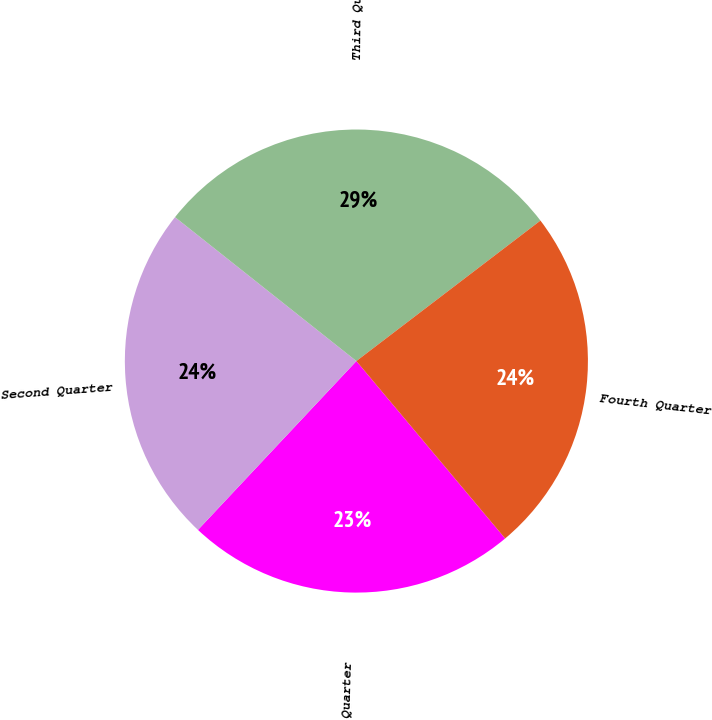Convert chart to OTSL. <chart><loc_0><loc_0><loc_500><loc_500><pie_chart><fcel>First Quarter<fcel>Second Quarter<fcel>Third Quarter<fcel>Fourth Quarter<nl><fcel>23.1%<fcel>23.68%<fcel>28.95%<fcel>24.27%<nl></chart> 